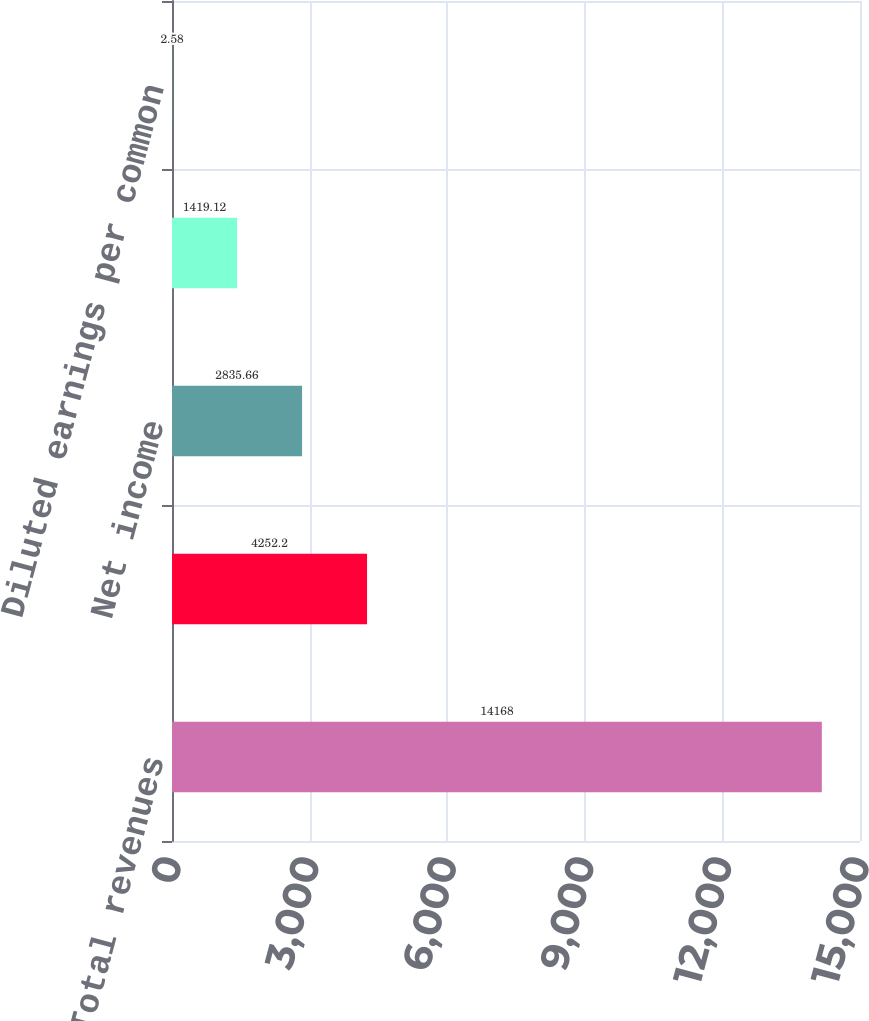Convert chart to OTSL. <chart><loc_0><loc_0><loc_500><loc_500><bar_chart><fcel>Total revenues<fcel>Income before income taxes and<fcel>Net income<fcel>Basic earnings per common<fcel>Diluted earnings per common<nl><fcel>14168<fcel>4252.2<fcel>2835.66<fcel>1419.12<fcel>2.58<nl></chart> 